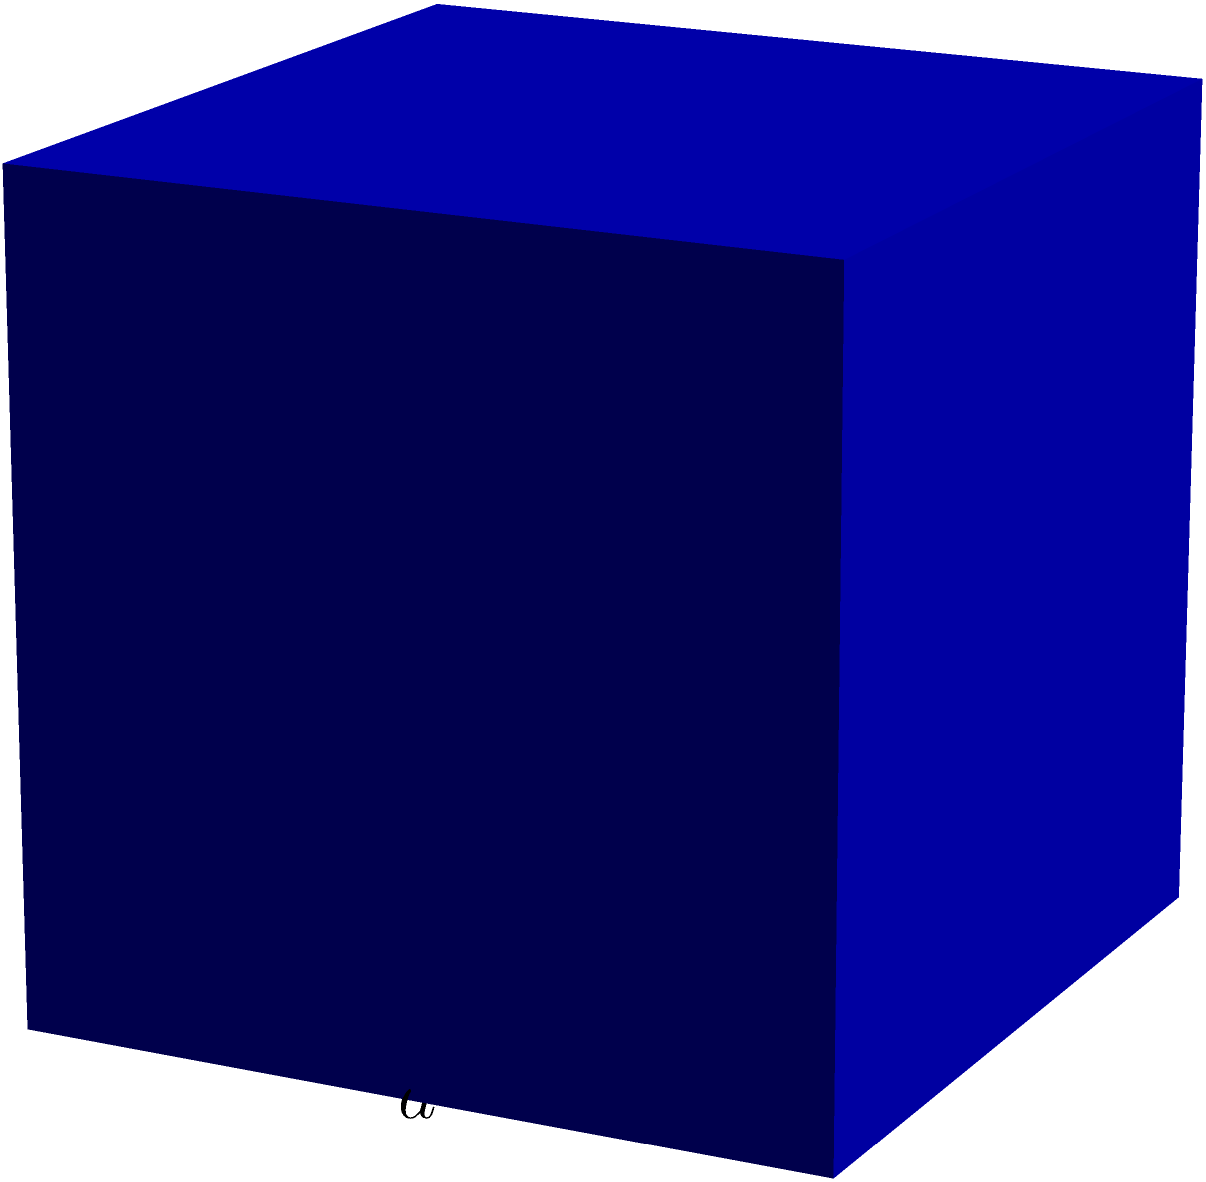A local food bank needs to store dry goods in cubic containers. If each container has an edge length of $a$ meters and the food bank needs to minimize material costs for manufacturing these containers, what is the surface area of each container in terms of $a$? How does this relate to the volume of goods that can be stored, and what sociological implications might this have for food distribution efficiency? To solve this problem, let's break it down into steps:

1) First, we need to calculate the surface area of a cube. A cube has 6 identical square faces.

2) The area of each face is $a^2$, where $a$ is the length of an edge.

3) Therefore, the total surface area of the cube is:
   $$\text{Surface Area} = 6a^2$$

4) The volume of the cube is:
   $$\text{Volume} = a^3$$

5) The relationship between surface area and volume is important here. As the edge length $a$ increases, the surface area increases by a factor of $a^2$, while the volume increases by a factor of $a^3$.

6) This means that larger containers will have a better volume-to-surface area ratio, which could be more cost-effective in terms of material usage.

7) Sociological implications:
   - Larger containers could reduce overall material costs, potentially allowing the food bank to allocate more resources to food acquisition.
   - However, larger containers might be harder to transport or distribute, especially to smaller households or individuals.
   - The choice of container size could impact the types and quantities of food distributed, affecting the nutritional balance offered to recipients.
   - Standardized container sizes could streamline logistics but might not adapt well to varying family sizes or diverse cultural food preferences.

8) The food bank would need to balance these factors to optimize their distribution efficiency while meeting the diverse needs of the community they serve.
Answer: $6a^2$ 